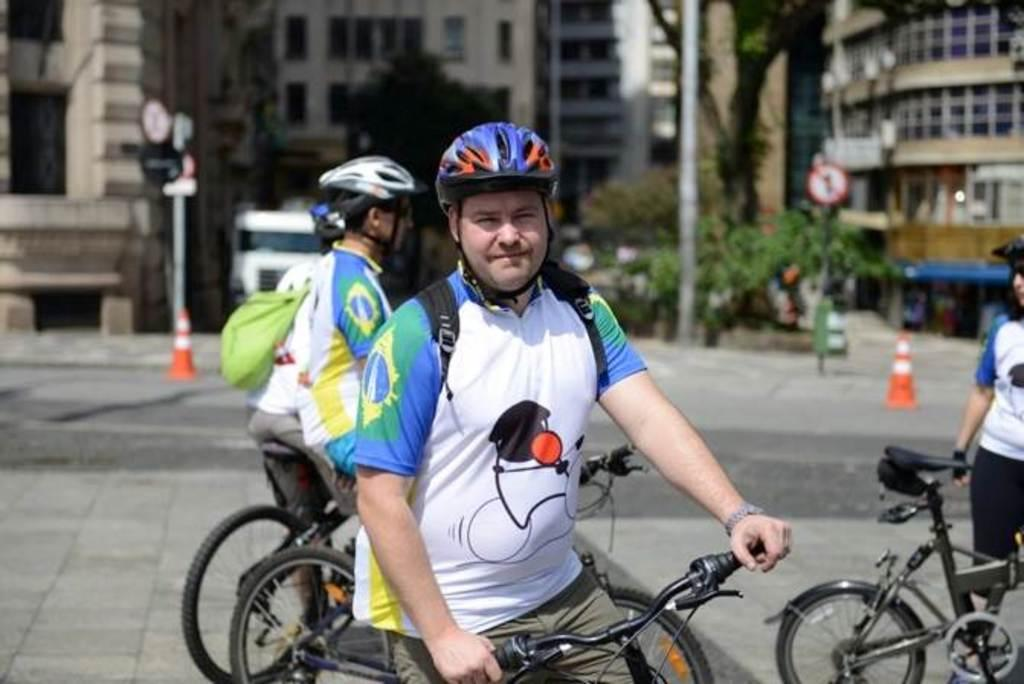What is the main subject of the image? The main subject of the image is a man on a cycle. What are the other persons in the image doing? The three other persons in the background of the image are also on cycles. Can you describe any objects in the image? There are two cones and poles in the image. What can be seen in the background of the image? There are buildings in the background of the image. What type of jewel is being discussed by the group in the image? There is no group present in the image, nor is there any discussion about a jewel. 